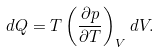Convert formula to latex. <formula><loc_0><loc_0><loc_500><loc_500>d Q = T \left ( \frac { \partial p } { \partial T } \right ) _ { V } d V .</formula> 